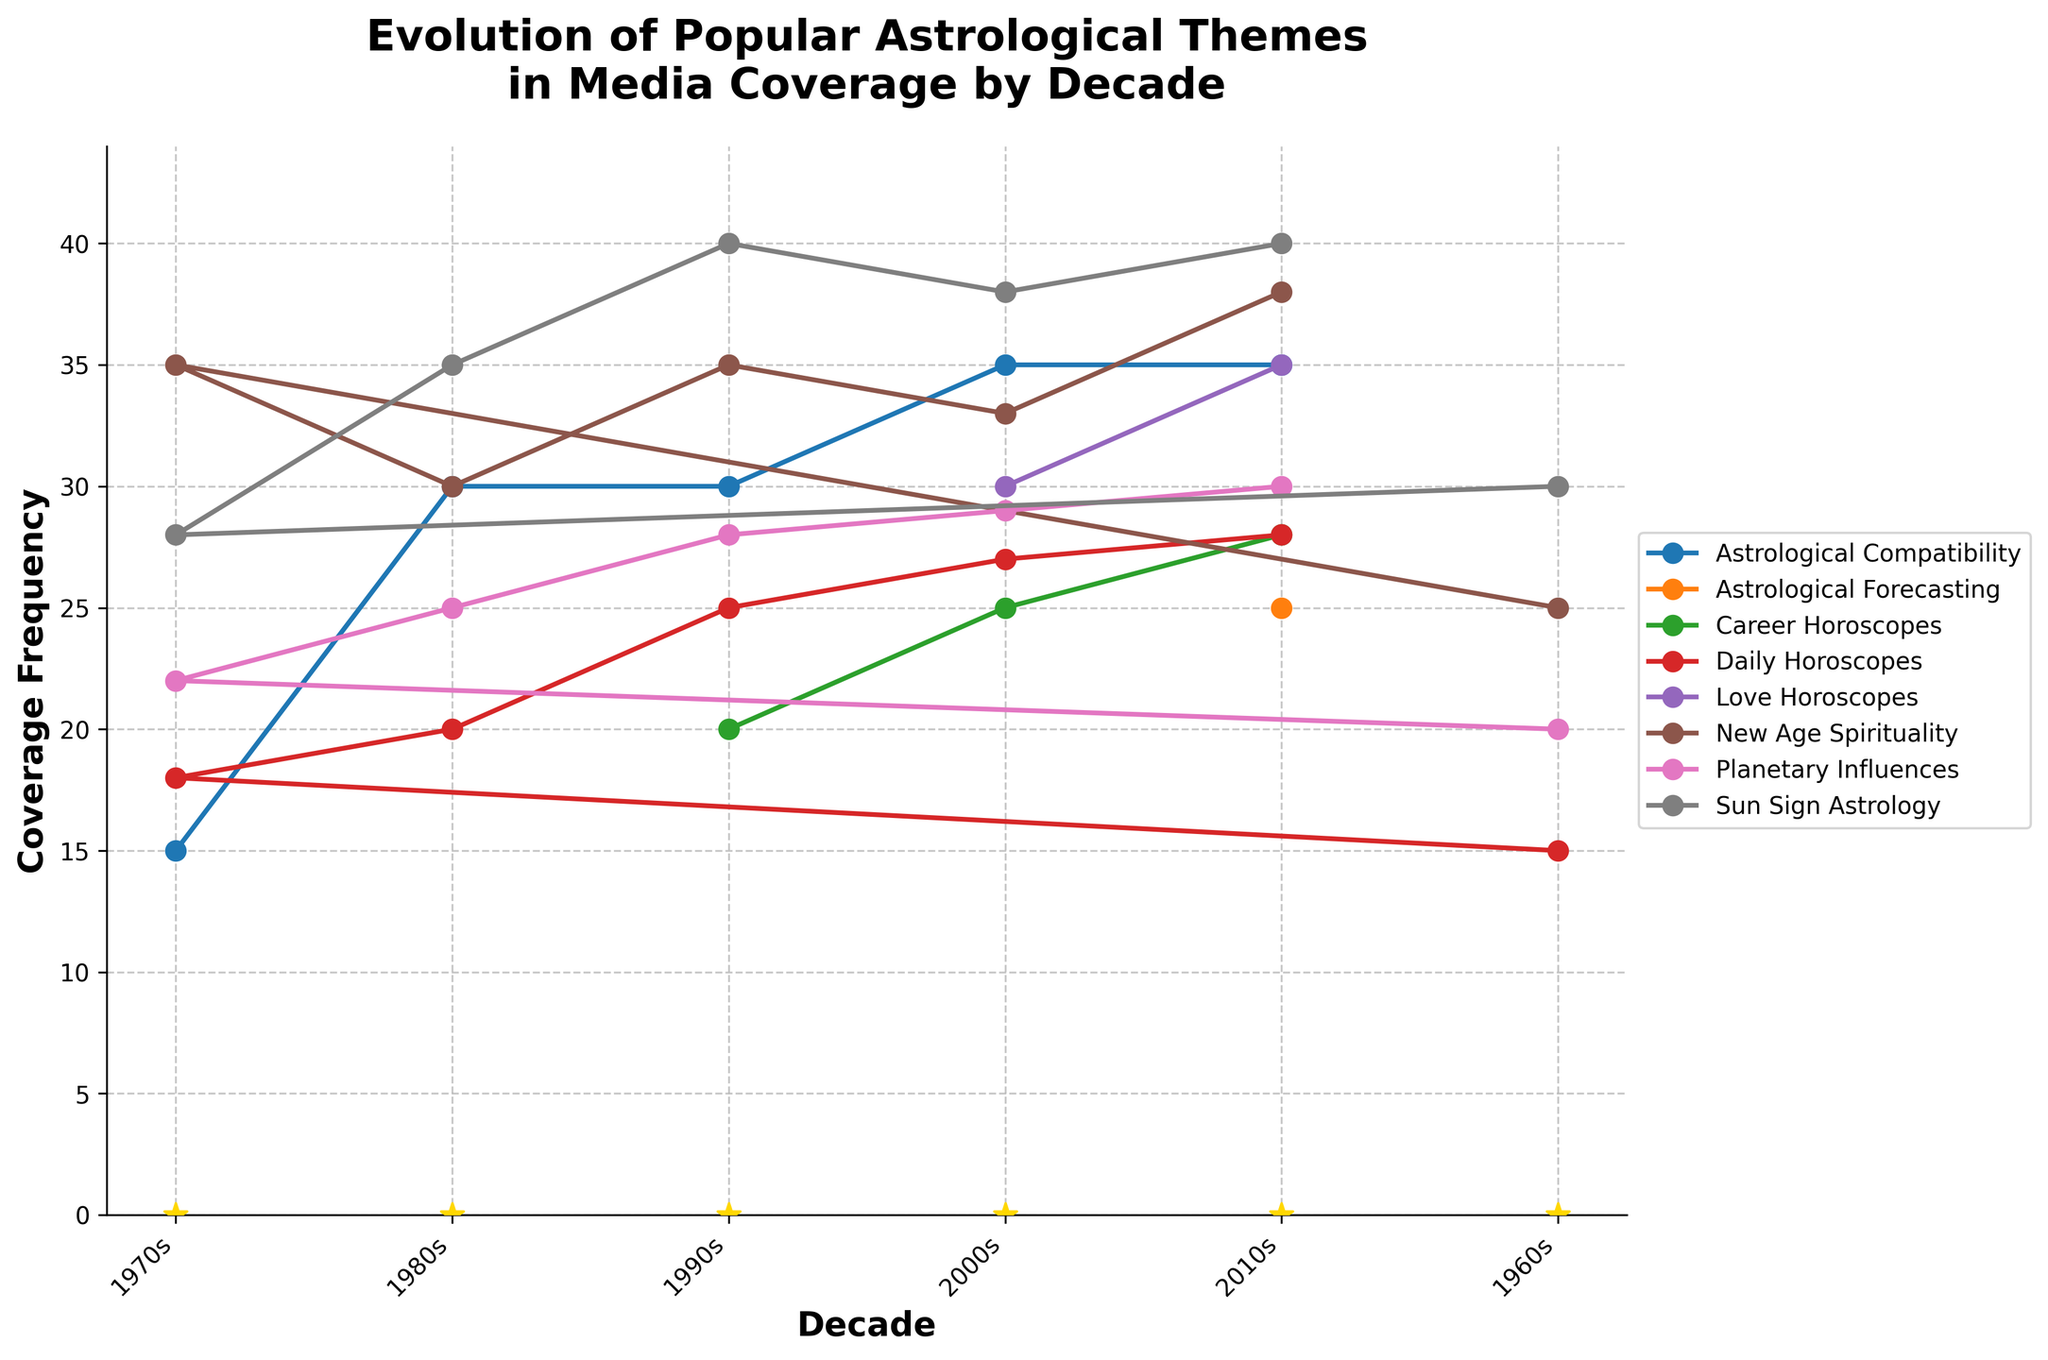What is the highest coverage frequency for "Sun Sign Astrology"? To find the highest coverage frequency for "Sun Sign Astrology," examine the peaks of the "Sun Sign Astrology" line. The highest peak occurs in the 2010s with a value of 40.
Answer: 40 Which theme had the lowest coverage frequency in the 1960s? To determine the theme with the lowest coverage frequency in the 1960s, compare the values for all themes in that decade. "Daily Horoscopes" has the lowest value of 15.
Answer: Daily Horoscopes How did the coverage for "New Age Spirituality" change from the 1970s to the 1980s? Look at the coverage frequency for "New Age Spirituality" in both decades. It increased from 35 in the 1970s to 30 in the 1980s, so the change is 5.
Answer: Decreased by 5 Which decade saw the introduction of "Career Horoscopes"? Identify the first occurrence of "Career Horoscopes" on the x-axis. It first appears in the 1990s.
Answer: 1990s What is the difference in coverage frequency between "Love Horoscopes" and "Astrological Forecasting" in the 2010s? Compare the values for "Love Horoscopes" and "Astrological Forecasting" in the 2010s. "Love Horoscopes" has a frequency of 35, while "Astrological Forecasting" has 25. The difference is 35 - 25.
Answer: 10 Which theme had the greatest increase in coverage from the 2000s to the 2010s? Calculate the increase for each theme between these decades and find the maximum. "New Age Spirituality" increased from 33 to 38, an increase of 5, which is the greatest.
Answer: New Age Spirituality Between 1960s and 2010s, which theme had the most consistent coverage frequency? Consistency implies minimal fluctuation over the decades. "Sun Sign Astrology" shows the most consistent values, around 30 to 40, compared to other themes that have larger variations.
Answer: Sun Sign Astrology What is the average coverage frequency for "Astrological Compatibility" across all decades? Calculate the average by adding up the values provided for each decade and dividing by the number of decades. (15+30+30+35+35 = 145) and divide by 5, giving an average of 29.
Answer: 29 How does the coverage of "Daily Horoscopes" in the 2010s compare to its coverage in the 1960s? Look at the values for "Daily Horoscopes" in these two decades. It increased from 15 in the 1960s to 28 in the 2010s, so it nearly doubled.
Answer: Nearly doubled What is the trend for "Planetary Influences" from the 1960s to the 2010s? Examine the line representing "Planetary Influences" across the decades from the 1960s to 2010s. Its trend is generally increasing over time.
Answer: Increasing 